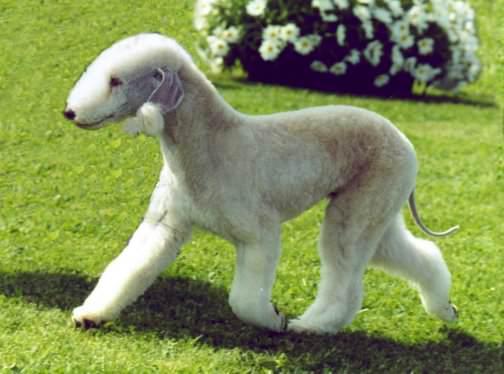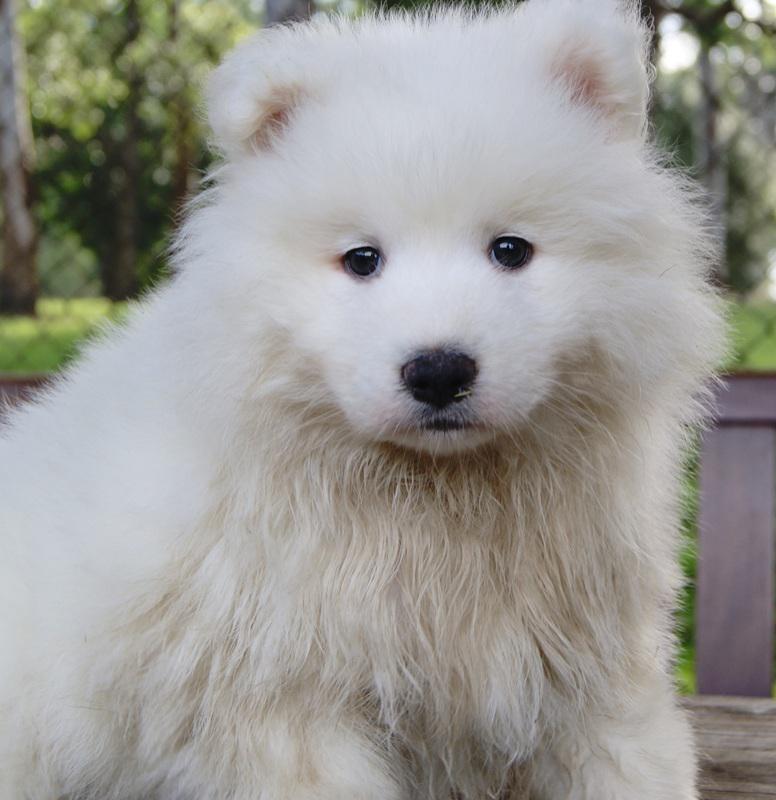The first image is the image on the left, the second image is the image on the right. Considering the images on both sides, is "There is a flowering plant behind one of the dogs." valid? Answer yes or no. Yes. The first image is the image on the left, the second image is the image on the right. Evaluate the accuracy of this statement regarding the images: "One white dog is shown with flowers in the background in one image.". Is it true? Answer yes or no. Yes. 